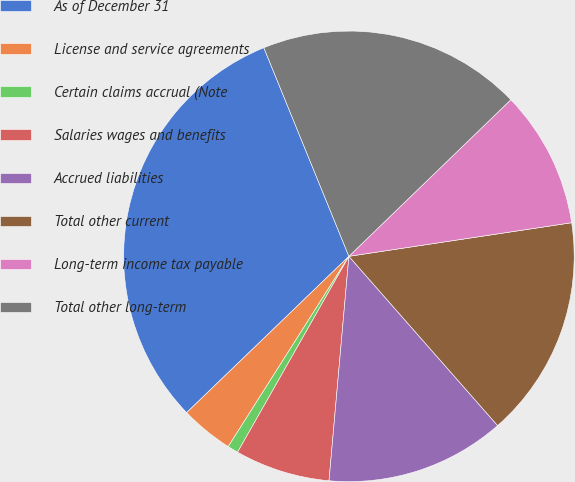<chart> <loc_0><loc_0><loc_500><loc_500><pie_chart><fcel>As of December 31<fcel>License and service agreements<fcel>Certain claims accrual (Note<fcel>Salaries wages and benefits<fcel>Accrued liabilities<fcel>Total other current<fcel>Long-term income tax payable<fcel>Total other long-term<nl><fcel>31.04%<fcel>3.8%<fcel>0.77%<fcel>6.82%<fcel>12.88%<fcel>15.91%<fcel>9.85%<fcel>18.93%<nl></chart> 